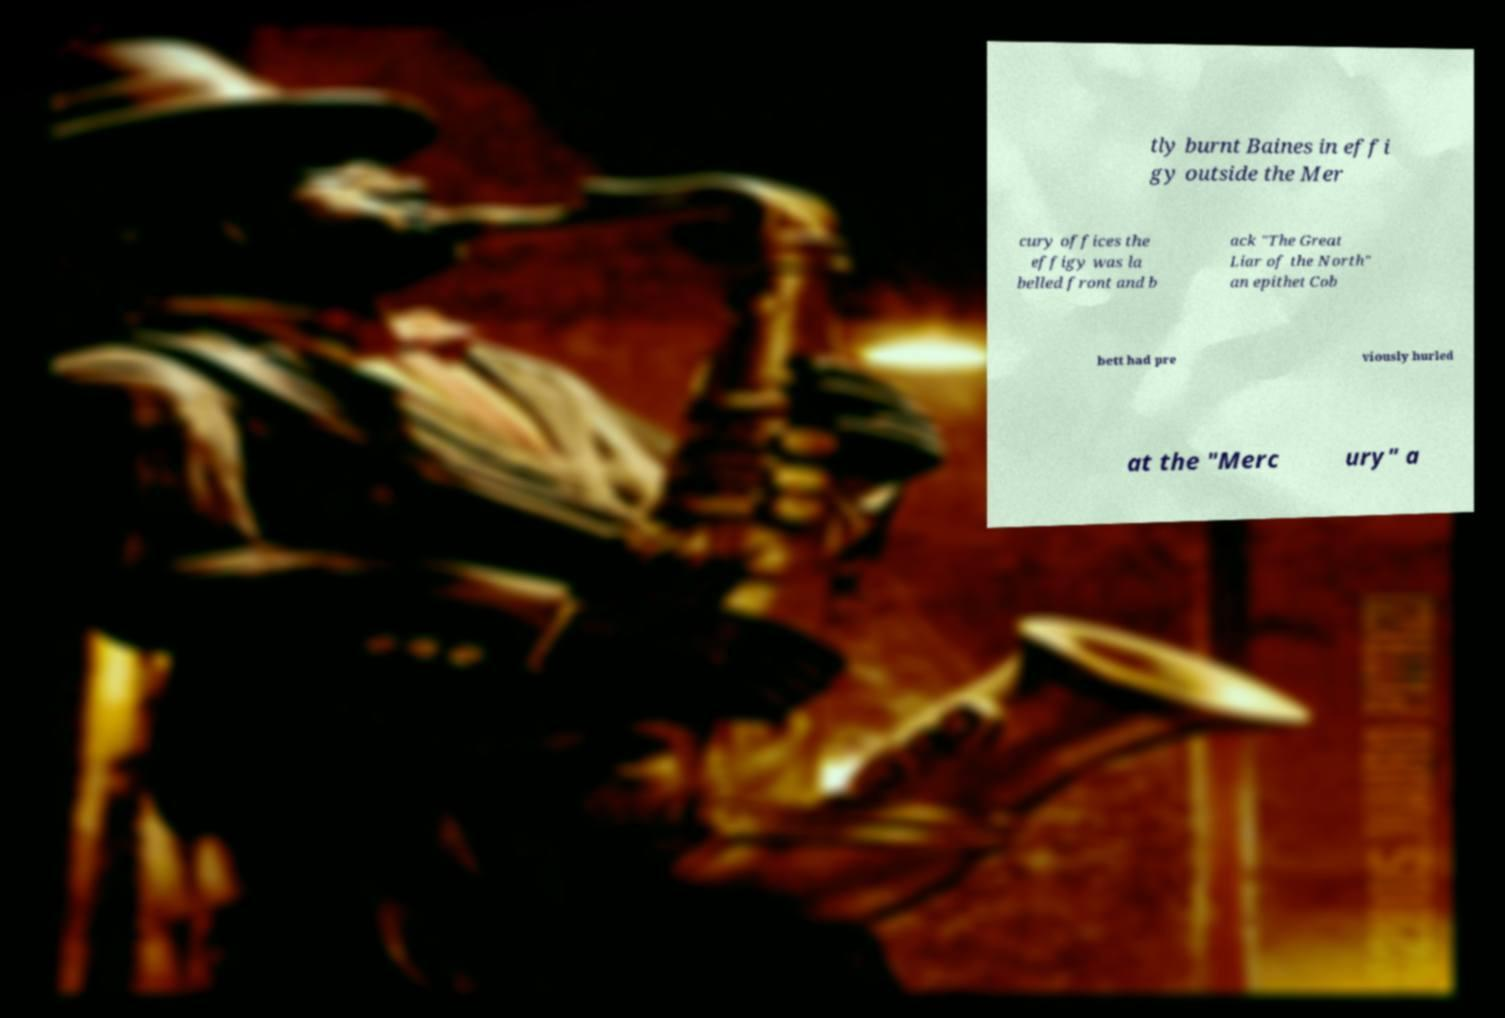There's text embedded in this image that I need extracted. Can you transcribe it verbatim? tly burnt Baines in effi gy outside the Mer cury offices the effigy was la belled front and b ack "The Great Liar of the North" an epithet Cob bett had pre viously hurled at the "Merc ury" a 